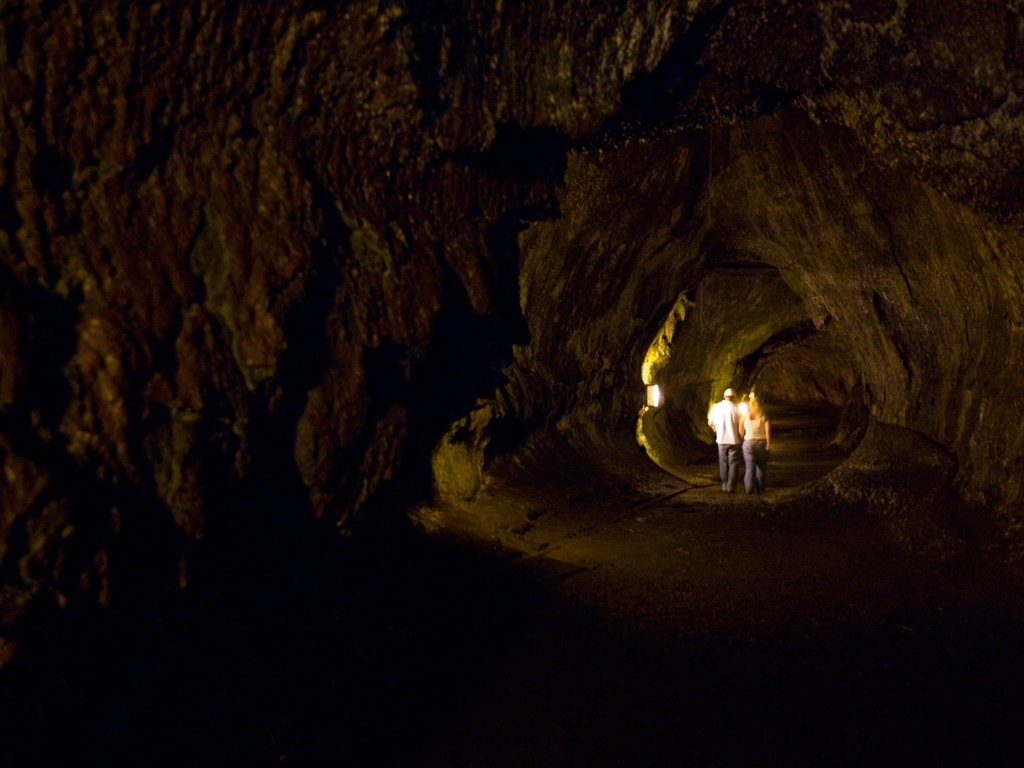Can you describe the geological features observable in the image? Certainly, the image showcases a cavernous environment with rugged rocky walls that indicate volcanic activity may have formed this cave. The curved lines and tube-like structure might suggest it's a lava tube, a natural conduit formed by flowing lava which moves beneath the hardened surface of a lava flow. The texture on the walls appears rough with variations in color, which are often characteristic of mineral deposits or variations in rock compositions. 